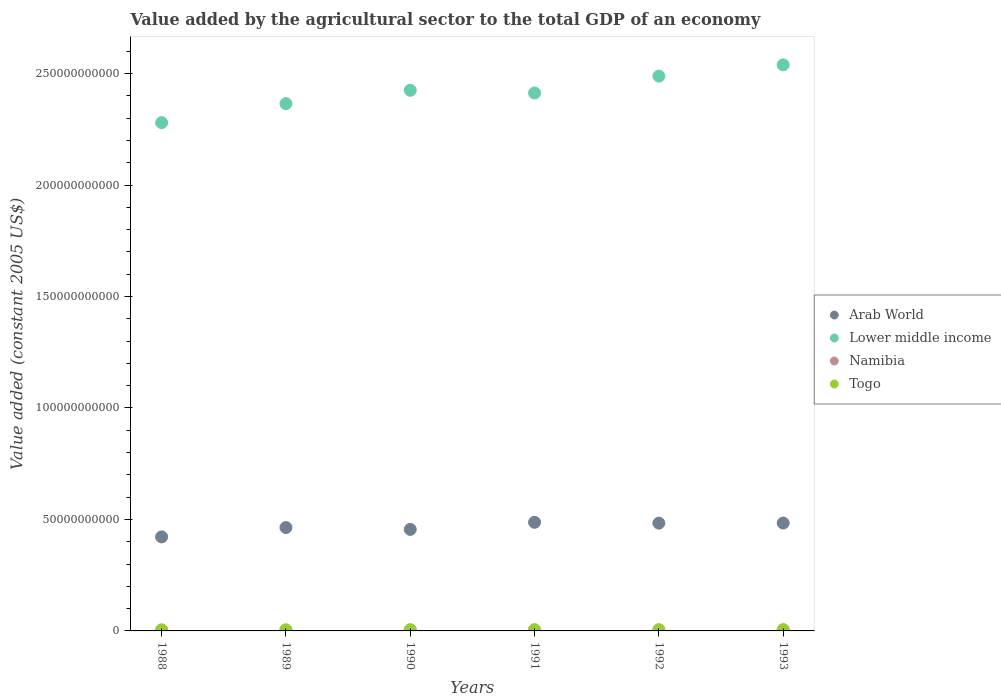How many different coloured dotlines are there?
Ensure brevity in your answer.  4. Is the number of dotlines equal to the number of legend labels?
Make the answer very short. Yes. What is the value added by the agricultural sector in Togo in 1992?
Offer a terse response. 5.30e+08. Across all years, what is the maximum value added by the agricultural sector in Lower middle income?
Provide a short and direct response. 2.54e+11. Across all years, what is the minimum value added by the agricultural sector in Togo?
Make the answer very short. 4.87e+08. In which year was the value added by the agricultural sector in Arab World minimum?
Your answer should be very brief. 1988. What is the total value added by the agricultural sector in Lower middle income in the graph?
Offer a very short reply. 1.45e+12. What is the difference between the value added by the agricultural sector in Togo in 1989 and that in 1991?
Ensure brevity in your answer.  -9.35e+06. What is the difference between the value added by the agricultural sector in Namibia in 1989 and the value added by the agricultural sector in Togo in 1990?
Give a very brief answer. -1.89e+08. What is the average value added by the agricultural sector in Arab World per year?
Provide a short and direct response. 4.66e+1. In the year 1990, what is the difference between the value added by the agricultural sector in Lower middle income and value added by the agricultural sector in Togo?
Provide a succinct answer. 2.42e+11. In how many years, is the value added by the agricultural sector in Namibia greater than 150000000000 US$?
Give a very brief answer. 0. What is the ratio of the value added by the agricultural sector in Arab World in 1988 to that in 1993?
Keep it short and to the point. 0.87. Is the value added by the agricultural sector in Lower middle income in 1989 less than that in 1990?
Provide a succinct answer. Yes. Is the difference between the value added by the agricultural sector in Lower middle income in 1990 and 1992 greater than the difference between the value added by the agricultural sector in Togo in 1990 and 1992?
Your answer should be compact. No. What is the difference between the highest and the second highest value added by the agricultural sector in Arab World?
Your response must be concise. 3.39e+08. What is the difference between the highest and the lowest value added by the agricultural sector in Togo?
Offer a terse response. 7.43e+07. Is the sum of the value added by the agricultural sector in Arab World in 1990 and 1993 greater than the maximum value added by the agricultural sector in Namibia across all years?
Give a very brief answer. Yes. Is it the case that in every year, the sum of the value added by the agricultural sector in Namibia and value added by the agricultural sector in Togo  is greater than the sum of value added by the agricultural sector in Arab World and value added by the agricultural sector in Lower middle income?
Provide a short and direct response. No. Is it the case that in every year, the sum of the value added by the agricultural sector in Arab World and value added by the agricultural sector in Namibia  is greater than the value added by the agricultural sector in Togo?
Provide a succinct answer. Yes. Does the value added by the agricultural sector in Namibia monotonically increase over the years?
Offer a terse response. No. How many dotlines are there?
Your response must be concise. 4. What is the difference between two consecutive major ticks on the Y-axis?
Your response must be concise. 5.00e+1. Are the values on the major ticks of Y-axis written in scientific E-notation?
Ensure brevity in your answer.  No. Does the graph contain grids?
Provide a succinct answer. No. Where does the legend appear in the graph?
Your response must be concise. Center right. What is the title of the graph?
Offer a terse response. Value added by the agricultural sector to the total GDP of an economy. Does "Sudan" appear as one of the legend labels in the graph?
Your response must be concise. No. What is the label or title of the Y-axis?
Offer a very short reply. Value added (constant 2005 US$). What is the Value added (constant 2005 US$) of Arab World in 1988?
Keep it short and to the point. 4.22e+1. What is the Value added (constant 2005 US$) in Lower middle income in 1988?
Your response must be concise. 2.28e+11. What is the Value added (constant 2005 US$) in Namibia in 1988?
Offer a very short reply. 3.42e+08. What is the Value added (constant 2005 US$) of Togo in 1988?
Give a very brief answer. 4.87e+08. What is the Value added (constant 2005 US$) in Arab World in 1989?
Make the answer very short. 4.64e+1. What is the Value added (constant 2005 US$) of Lower middle income in 1989?
Provide a short and direct response. 2.37e+11. What is the Value added (constant 2005 US$) in Namibia in 1989?
Give a very brief answer. 3.41e+08. What is the Value added (constant 2005 US$) of Togo in 1989?
Provide a short and direct response. 5.14e+08. What is the Value added (constant 2005 US$) in Arab World in 1990?
Your answer should be very brief. 4.55e+1. What is the Value added (constant 2005 US$) of Lower middle income in 1990?
Offer a terse response. 2.42e+11. What is the Value added (constant 2005 US$) of Namibia in 1990?
Provide a short and direct response. 4.04e+08. What is the Value added (constant 2005 US$) in Togo in 1990?
Offer a very short reply. 5.29e+08. What is the Value added (constant 2005 US$) in Arab World in 1991?
Give a very brief answer. 4.87e+1. What is the Value added (constant 2005 US$) of Lower middle income in 1991?
Give a very brief answer. 2.41e+11. What is the Value added (constant 2005 US$) of Namibia in 1991?
Keep it short and to the point. 4.61e+08. What is the Value added (constant 2005 US$) in Togo in 1991?
Your answer should be very brief. 5.23e+08. What is the Value added (constant 2005 US$) of Arab World in 1992?
Provide a succinct answer. 4.84e+1. What is the Value added (constant 2005 US$) in Lower middle income in 1992?
Provide a short and direct response. 2.49e+11. What is the Value added (constant 2005 US$) of Namibia in 1992?
Give a very brief answer. 4.40e+08. What is the Value added (constant 2005 US$) of Togo in 1992?
Ensure brevity in your answer.  5.30e+08. What is the Value added (constant 2005 US$) in Arab World in 1993?
Offer a terse response. 4.84e+1. What is the Value added (constant 2005 US$) in Lower middle income in 1993?
Your answer should be very brief. 2.54e+11. What is the Value added (constant 2005 US$) in Namibia in 1993?
Give a very brief answer. 4.82e+08. What is the Value added (constant 2005 US$) of Togo in 1993?
Provide a succinct answer. 5.61e+08. Across all years, what is the maximum Value added (constant 2005 US$) of Arab World?
Give a very brief answer. 4.87e+1. Across all years, what is the maximum Value added (constant 2005 US$) of Lower middle income?
Offer a terse response. 2.54e+11. Across all years, what is the maximum Value added (constant 2005 US$) of Namibia?
Keep it short and to the point. 4.82e+08. Across all years, what is the maximum Value added (constant 2005 US$) in Togo?
Your answer should be very brief. 5.61e+08. Across all years, what is the minimum Value added (constant 2005 US$) of Arab World?
Your answer should be very brief. 4.22e+1. Across all years, what is the minimum Value added (constant 2005 US$) in Lower middle income?
Provide a short and direct response. 2.28e+11. Across all years, what is the minimum Value added (constant 2005 US$) in Namibia?
Your answer should be compact. 3.41e+08. Across all years, what is the minimum Value added (constant 2005 US$) of Togo?
Ensure brevity in your answer.  4.87e+08. What is the total Value added (constant 2005 US$) of Arab World in the graph?
Provide a short and direct response. 2.80e+11. What is the total Value added (constant 2005 US$) in Lower middle income in the graph?
Provide a succinct answer. 1.45e+12. What is the total Value added (constant 2005 US$) of Namibia in the graph?
Offer a very short reply. 2.47e+09. What is the total Value added (constant 2005 US$) in Togo in the graph?
Ensure brevity in your answer.  3.14e+09. What is the difference between the Value added (constant 2005 US$) of Arab World in 1988 and that in 1989?
Ensure brevity in your answer.  -4.19e+09. What is the difference between the Value added (constant 2005 US$) in Lower middle income in 1988 and that in 1989?
Your response must be concise. -8.54e+09. What is the difference between the Value added (constant 2005 US$) in Namibia in 1988 and that in 1989?
Make the answer very short. 1.64e+06. What is the difference between the Value added (constant 2005 US$) in Togo in 1988 and that in 1989?
Make the answer very short. -2.68e+07. What is the difference between the Value added (constant 2005 US$) of Arab World in 1988 and that in 1990?
Offer a very short reply. -3.36e+09. What is the difference between the Value added (constant 2005 US$) in Lower middle income in 1988 and that in 1990?
Provide a short and direct response. -1.45e+1. What is the difference between the Value added (constant 2005 US$) in Namibia in 1988 and that in 1990?
Offer a terse response. -6.18e+07. What is the difference between the Value added (constant 2005 US$) of Togo in 1988 and that in 1990?
Give a very brief answer. -4.22e+07. What is the difference between the Value added (constant 2005 US$) in Arab World in 1988 and that in 1991?
Your answer should be compact. -6.56e+09. What is the difference between the Value added (constant 2005 US$) of Lower middle income in 1988 and that in 1991?
Ensure brevity in your answer.  -1.33e+1. What is the difference between the Value added (constant 2005 US$) in Namibia in 1988 and that in 1991?
Offer a very short reply. -1.18e+08. What is the difference between the Value added (constant 2005 US$) in Togo in 1988 and that in 1991?
Your answer should be compact. -3.61e+07. What is the difference between the Value added (constant 2005 US$) in Arab World in 1988 and that in 1992?
Provide a short and direct response. -6.18e+09. What is the difference between the Value added (constant 2005 US$) in Lower middle income in 1988 and that in 1992?
Your answer should be compact. -2.09e+1. What is the difference between the Value added (constant 2005 US$) of Namibia in 1988 and that in 1992?
Offer a very short reply. -9.81e+07. What is the difference between the Value added (constant 2005 US$) in Togo in 1988 and that in 1992?
Your answer should be very brief. -4.25e+07. What is the difference between the Value added (constant 2005 US$) in Arab World in 1988 and that in 1993?
Offer a very short reply. -6.22e+09. What is the difference between the Value added (constant 2005 US$) of Lower middle income in 1988 and that in 1993?
Keep it short and to the point. -2.59e+1. What is the difference between the Value added (constant 2005 US$) in Namibia in 1988 and that in 1993?
Provide a succinct answer. -1.39e+08. What is the difference between the Value added (constant 2005 US$) of Togo in 1988 and that in 1993?
Provide a short and direct response. -7.43e+07. What is the difference between the Value added (constant 2005 US$) of Arab World in 1989 and that in 1990?
Offer a very short reply. 8.31e+08. What is the difference between the Value added (constant 2005 US$) of Lower middle income in 1989 and that in 1990?
Your response must be concise. -5.97e+09. What is the difference between the Value added (constant 2005 US$) in Namibia in 1989 and that in 1990?
Provide a succinct answer. -6.34e+07. What is the difference between the Value added (constant 2005 US$) in Togo in 1989 and that in 1990?
Keep it short and to the point. -1.54e+07. What is the difference between the Value added (constant 2005 US$) in Arab World in 1989 and that in 1991?
Offer a terse response. -2.36e+09. What is the difference between the Value added (constant 2005 US$) of Lower middle income in 1989 and that in 1991?
Your response must be concise. -4.78e+09. What is the difference between the Value added (constant 2005 US$) in Namibia in 1989 and that in 1991?
Your answer should be compact. -1.20e+08. What is the difference between the Value added (constant 2005 US$) of Togo in 1989 and that in 1991?
Keep it short and to the point. -9.35e+06. What is the difference between the Value added (constant 2005 US$) in Arab World in 1989 and that in 1992?
Offer a very short reply. -1.98e+09. What is the difference between the Value added (constant 2005 US$) of Lower middle income in 1989 and that in 1992?
Keep it short and to the point. -1.23e+1. What is the difference between the Value added (constant 2005 US$) of Namibia in 1989 and that in 1992?
Provide a short and direct response. -9.97e+07. What is the difference between the Value added (constant 2005 US$) in Togo in 1989 and that in 1992?
Provide a short and direct response. -1.57e+07. What is the difference between the Value added (constant 2005 US$) in Arab World in 1989 and that in 1993?
Your response must be concise. -2.02e+09. What is the difference between the Value added (constant 2005 US$) of Lower middle income in 1989 and that in 1993?
Make the answer very short. -1.74e+1. What is the difference between the Value added (constant 2005 US$) of Namibia in 1989 and that in 1993?
Your answer should be compact. -1.41e+08. What is the difference between the Value added (constant 2005 US$) of Togo in 1989 and that in 1993?
Your answer should be very brief. -4.75e+07. What is the difference between the Value added (constant 2005 US$) in Arab World in 1990 and that in 1991?
Your answer should be compact. -3.19e+09. What is the difference between the Value added (constant 2005 US$) in Lower middle income in 1990 and that in 1991?
Provide a short and direct response. 1.19e+09. What is the difference between the Value added (constant 2005 US$) in Namibia in 1990 and that in 1991?
Your answer should be compact. -5.66e+07. What is the difference between the Value added (constant 2005 US$) in Togo in 1990 and that in 1991?
Your answer should be compact. 6.03e+06. What is the difference between the Value added (constant 2005 US$) of Arab World in 1990 and that in 1992?
Give a very brief answer. -2.81e+09. What is the difference between the Value added (constant 2005 US$) in Lower middle income in 1990 and that in 1992?
Offer a very short reply. -6.36e+09. What is the difference between the Value added (constant 2005 US$) in Namibia in 1990 and that in 1992?
Provide a short and direct response. -3.63e+07. What is the difference between the Value added (constant 2005 US$) in Togo in 1990 and that in 1992?
Give a very brief answer. -3.74e+05. What is the difference between the Value added (constant 2005 US$) of Arab World in 1990 and that in 1993?
Make the answer very short. -2.86e+09. What is the difference between the Value added (constant 2005 US$) of Lower middle income in 1990 and that in 1993?
Make the answer very short. -1.14e+1. What is the difference between the Value added (constant 2005 US$) of Namibia in 1990 and that in 1993?
Your answer should be very brief. -7.75e+07. What is the difference between the Value added (constant 2005 US$) in Togo in 1990 and that in 1993?
Give a very brief answer. -3.21e+07. What is the difference between the Value added (constant 2005 US$) of Arab World in 1991 and that in 1992?
Offer a terse response. 3.80e+08. What is the difference between the Value added (constant 2005 US$) in Lower middle income in 1991 and that in 1992?
Keep it short and to the point. -7.55e+09. What is the difference between the Value added (constant 2005 US$) in Namibia in 1991 and that in 1992?
Provide a short and direct response. 2.03e+07. What is the difference between the Value added (constant 2005 US$) in Togo in 1991 and that in 1992?
Make the answer very short. -6.40e+06. What is the difference between the Value added (constant 2005 US$) in Arab World in 1991 and that in 1993?
Provide a short and direct response. 3.39e+08. What is the difference between the Value added (constant 2005 US$) in Lower middle income in 1991 and that in 1993?
Keep it short and to the point. -1.26e+1. What is the difference between the Value added (constant 2005 US$) in Namibia in 1991 and that in 1993?
Ensure brevity in your answer.  -2.09e+07. What is the difference between the Value added (constant 2005 US$) in Togo in 1991 and that in 1993?
Give a very brief answer. -3.81e+07. What is the difference between the Value added (constant 2005 US$) of Arab World in 1992 and that in 1993?
Provide a succinct answer. -4.10e+07. What is the difference between the Value added (constant 2005 US$) of Lower middle income in 1992 and that in 1993?
Ensure brevity in your answer.  -5.06e+09. What is the difference between the Value added (constant 2005 US$) in Namibia in 1992 and that in 1993?
Keep it short and to the point. -4.11e+07. What is the difference between the Value added (constant 2005 US$) in Togo in 1992 and that in 1993?
Your answer should be very brief. -3.17e+07. What is the difference between the Value added (constant 2005 US$) of Arab World in 1988 and the Value added (constant 2005 US$) of Lower middle income in 1989?
Ensure brevity in your answer.  -1.94e+11. What is the difference between the Value added (constant 2005 US$) of Arab World in 1988 and the Value added (constant 2005 US$) of Namibia in 1989?
Your answer should be compact. 4.18e+1. What is the difference between the Value added (constant 2005 US$) of Arab World in 1988 and the Value added (constant 2005 US$) of Togo in 1989?
Your answer should be compact. 4.17e+1. What is the difference between the Value added (constant 2005 US$) of Lower middle income in 1988 and the Value added (constant 2005 US$) of Namibia in 1989?
Make the answer very short. 2.28e+11. What is the difference between the Value added (constant 2005 US$) of Lower middle income in 1988 and the Value added (constant 2005 US$) of Togo in 1989?
Keep it short and to the point. 2.27e+11. What is the difference between the Value added (constant 2005 US$) in Namibia in 1988 and the Value added (constant 2005 US$) in Togo in 1989?
Your answer should be very brief. -1.72e+08. What is the difference between the Value added (constant 2005 US$) of Arab World in 1988 and the Value added (constant 2005 US$) of Lower middle income in 1990?
Your response must be concise. -2.00e+11. What is the difference between the Value added (constant 2005 US$) in Arab World in 1988 and the Value added (constant 2005 US$) in Namibia in 1990?
Provide a succinct answer. 4.18e+1. What is the difference between the Value added (constant 2005 US$) in Arab World in 1988 and the Value added (constant 2005 US$) in Togo in 1990?
Provide a short and direct response. 4.16e+1. What is the difference between the Value added (constant 2005 US$) of Lower middle income in 1988 and the Value added (constant 2005 US$) of Namibia in 1990?
Give a very brief answer. 2.28e+11. What is the difference between the Value added (constant 2005 US$) in Lower middle income in 1988 and the Value added (constant 2005 US$) in Togo in 1990?
Provide a succinct answer. 2.27e+11. What is the difference between the Value added (constant 2005 US$) of Namibia in 1988 and the Value added (constant 2005 US$) of Togo in 1990?
Give a very brief answer. -1.87e+08. What is the difference between the Value added (constant 2005 US$) of Arab World in 1988 and the Value added (constant 2005 US$) of Lower middle income in 1991?
Provide a short and direct response. -1.99e+11. What is the difference between the Value added (constant 2005 US$) of Arab World in 1988 and the Value added (constant 2005 US$) of Namibia in 1991?
Offer a terse response. 4.17e+1. What is the difference between the Value added (constant 2005 US$) in Arab World in 1988 and the Value added (constant 2005 US$) in Togo in 1991?
Give a very brief answer. 4.16e+1. What is the difference between the Value added (constant 2005 US$) of Lower middle income in 1988 and the Value added (constant 2005 US$) of Namibia in 1991?
Keep it short and to the point. 2.28e+11. What is the difference between the Value added (constant 2005 US$) of Lower middle income in 1988 and the Value added (constant 2005 US$) of Togo in 1991?
Offer a very short reply. 2.27e+11. What is the difference between the Value added (constant 2005 US$) of Namibia in 1988 and the Value added (constant 2005 US$) of Togo in 1991?
Your response must be concise. -1.81e+08. What is the difference between the Value added (constant 2005 US$) in Arab World in 1988 and the Value added (constant 2005 US$) in Lower middle income in 1992?
Your response must be concise. -2.07e+11. What is the difference between the Value added (constant 2005 US$) of Arab World in 1988 and the Value added (constant 2005 US$) of Namibia in 1992?
Provide a succinct answer. 4.17e+1. What is the difference between the Value added (constant 2005 US$) in Arab World in 1988 and the Value added (constant 2005 US$) in Togo in 1992?
Offer a very short reply. 4.16e+1. What is the difference between the Value added (constant 2005 US$) in Lower middle income in 1988 and the Value added (constant 2005 US$) in Namibia in 1992?
Give a very brief answer. 2.28e+11. What is the difference between the Value added (constant 2005 US$) in Lower middle income in 1988 and the Value added (constant 2005 US$) in Togo in 1992?
Keep it short and to the point. 2.27e+11. What is the difference between the Value added (constant 2005 US$) in Namibia in 1988 and the Value added (constant 2005 US$) in Togo in 1992?
Ensure brevity in your answer.  -1.87e+08. What is the difference between the Value added (constant 2005 US$) of Arab World in 1988 and the Value added (constant 2005 US$) of Lower middle income in 1993?
Make the answer very short. -2.12e+11. What is the difference between the Value added (constant 2005 US$) in Arab World in 1988 and the Value added (constant 2005 US$) in Namibia in 1993?
Offer a terse response. 4.17e+1. What is the difference between the Value added (constant 2005 US$) in Arab World in 1988 and the Value added (constant 2005 US$) in Togo in 1993?
Your answer should be compact. 4.16e+1. What is the difference between the Value added (constant 2005 US$) of Lower middle income in 1988 and the Value added (constant 2005 US$) of Namibia in 1993?
Keep it short and to the point. 2.27e+11. What is the difference between the Value added (constant 2005 US$) in Lower middle income in 1988 and the Value added (constant 2005 US$) in Togo in 1993?
Ensure brevity in your answer.  2.27e+11. What is the difference between the Value added (constant 2005 US$) in Namibia in 1988 and the Value added (constant 2005 US$) in Togo in 1993?
Offer a terse response. -2.19e+08. What is the difference between the Value added (constant 2005 US$) of Arab World in 1989 and the Value added (constant 2005 US$) of Lower middle income in 1990?
Your answer should be compact. -1.96e+11. What is the difference between the Value added (constant 2005 US$) of Arab World in 1989 and the Value added (constant 2005 US$) of Namibia in 1990?
Provide a succinct answer. 4.60e+1. What is the difference between the Value added (constant 2005 US$) in Arab World in 1989 and the Value added (constant 2005 US$) in Togo in 1990?
Offer a very short reply. 4.58e+1. What is the difference between the Value added (constant 2005 US$) in Lower middle income in 1989 and the Value added (constant 2005 US$) in Namibia in 1990?
Ensure brevity in your answer.  2.36e+11. What is the difference between the Value added (constant 2005 US$) in Lower middle income in 1989 and the Value added (constant 2005 US$) in Togo in 1990?
Ensure brevity in your answer.  2.36e+11. What is the difference between the Value added (constant 2005 US$) in Namibia in 1989 and the Value added (constant 2005 US$) in Togo in 1990?
Your response must be concise. -1.89e+08. What is the difference between the Value added (constant 2005 US$) in Arab World in 1989 and the Value added (constant 2005 US$) in Lower middle income in 1991?
Offer a very short reply. -1.95e+11. What is the difference between the Value added (constant 2005 US$) in Arab World in 1989 and the Value added (constant 2005 US$) in Namibia in 1991?
Your answer should be very brief. 4.59e+1. What is the difference between the Value added (constant 2005 US$) of Arab World in 1989 and the Value added (constant 2005 US$) of Togo in 1991?
Offer a terse response. 4.58e+1. What is the difference between the Value added (constant 2005 US$) of Lower middle income in 1989 and the Value added (constant 2005 US$) of Namibia in 1991?
Provide a succinct answer. 2.36e+11. What is the difference between the Value added (constant 2005 US$) of Lower middle income in 1989 and the Value added (constant 2005 US$) of Togo in 1991?
Provide a short and direct response. 2.36e+11. What is the difference between the Value added (constant 2005 US$) in Namibia in 1989 and the Value added (constant 2005 US$) in Togo in 1991?
Your response must be concise. -1.82e+08. What is the difference between the Value added (constant 2005 US$) of Arab World in 1989 and the Value added (constant 2005 US$) of Lower middle income in 1992?
Give a very brief answer. -2.02e+11. What is the difference between the Value added (constant 2005 US$) of Arab World in 1989 and the Value added (constant 2005 US$) of Namibia in 1992?
Offer a terse response. 4.59e+1. What is the difference between the Value added (constant 2005 US$) of Arab World in 1989 and the Value added (constant 2005 US$) of Togo in 1992?
Make the answer very short. 4.58e+1. What is the difference between the Value added (constant 2005 US$) of Lower middle income in 1989 and the Value added (constant 2005 US$) of Namibia in 1992?
Your answer should be compact. 2.36e+11. What is the difference between the Value added (constant 2005 US$) of Lower middle income in 1989 and the Value added (constant 2005 US$) of Togo in 1992?
Your response must be concise. 2.36e+11. What is the difference between the Value added (constant 2005 US$) of Namibia in 1989 and the Value added (constant 2005 US$) of Togo in 1992?
Make the answer very short. -1.89e+08. What is the difference between the Value added (constant 2005 US$) of Arab World in 1989 and the Value added (constant 2005 US$) of Lower middle income in 1993?
Give a very brief answer. -2.08e+11. What is the difference between the Value added (constant 2005 US$) of Arab World in 1989 and the Value added (constant 2005 US$) of Namibia in 1993?
Offer a terse response. 4.59e+1. What is the difference between the Value added (constant 2005 US$) in Arab World in 1989 and the Value added (constant 2005 US$) in Togo in 1993?
Keep it short and to the point. 4.58e+1. What is the difference between the Value added (constant 2005 US$) of Lower middle income in 1989 and the Value added (constant 2005 US$) of Namibia in 1993?
Give a very brief answer. 2.36e+11. What is the difference between the Value added (constant 2005 US$) in Lower middle income in 1989 and the Value added (constant 2005 US$) in Togo in 1993?
Provide a succinct answer. 2.36e+11. What is the difference between the Value added (constant 2005 US$) of Namibia in 1989 and the Value added (constant 2005 US$) of Togo in 1993?
Ensure brevity in your answer.  -2.21e+08. What is the difference between the Value added (constant 2005 US$) in Arab World in 1990 and the Value added (constant 2005 US$) in Lower middle income in 1991?
Your answer should be very brief. -1.96e+11. What is the difference between the Value added (constant 2005 US$) of Arab World in 1990 and the Value added (constant 2005 US$) of Namibia in 1991?
Give a very brief answer. 4.51e+1. What is the difference between the Value added (constant 2005 US$) in Arab World in 1990 and the Value added (constant 2005 US$) in Togo in 1991?
Make the answer very short. 4.50e+1. What is the difference between the Value added (constant 2005 US$) in Lower middle income in 1990 and the Value added (constant 2005 US$) in Namibia in 1991?
Offer a terse response. 2.42e+11. What is the difference between the Value added (constant 2005 US$) of Lower middle income in 1990 and the Value added (constant 2005 US$) of Togo in 1991?
Offer a very short reply. 2.42e+11. What is the difference between the Value added (constant 2005 US$) of Namibia in 1990 and the Value added (constant 2005 US$) of Togo in 1991?
Make the answer very short. -1.19e+08. What is the difference between the Value added (constant 2005 US$) in Arab World in 1990 and the Value added (constant 2005 US$) in Lower middle income in 1992?
Make the answer very short. -2.03e+11. What is the difference between the Value added (constant 2005 US$) of Arab World in 1990 and the Value added (constant 2005 US$) of Namibia in 1992?
Keep it short and to the point. 4.51e+1. What is the difference between the Value added (constant 2005 US$) in Arab World in 1990 and the Value added (constant 2005 US$) in Togo in 1992?
Make the answer very short. 4.50e+1. What is the difference between the Value added (constant 2005 US$) of Lower middle income in 1990 and the Value added (constant 2005 US$) of Namibia in 1992?
Provide a succinct answer. 2.42e+11. What is the difference between the Value added (constant 2005 US$) of Lower middle income in 1990 and the Value added (constant 2005 US$) of Togo in 1992?
Ensure brevity in your answer.  2.42e+11. What is the difference between the Value added (constant 2005 US$) in Namibia in 1990 and the Value added (constant 2005 US$) in Togo in 1992?
Offer a very short reply. -1.25e+08. What is the difference between the Value added (constant 2005 US$) of Arab World in 1990 and the Value added (constant 2005 US$) of Lower middle income in 1993?
Give a very brief answer. -2.08e+11. What is the difference between the Value added (constant 2005 US$) of Arab World in 1990 and the Value added (constant 2005 US$) of Namibia in 1993?
Provide a succinct answer. 4.51e+1. What is the difference between the Value added (constant 2005 US$) of Arab World in 1990 and the Value added (constant 2005 US$) of Togo in 1993?
Ensure brevity in your answer.  4.50e+1. What is the difference between the Value added (constant 2005 US$) of Lower middle income in 1990 and the Value added (constant 2005 US$) of Namibia in 1993?
Your response must be concise. 2.42e+11. What is the difference between the Value added (constant 2005 US$) of Lower middle income in 1990 and the Value added (constant 2005 US$) of Togo in 1993?
Make the answer very short. 2.42e+11. What is the difference between the Value added (constant 2005 US$) in Namibia in 1990 and the Value added (constant 2005 US$) in Togo in 1993?
Offer a terse response. -1.57e+08. What is the difference between the Value added (constant 2005 US$) in Arab World in 1991 and the Value added (constant 2005 US$) in Lower middle income in 1992?
Provide a succinct answer. -2.00e+11. What is the difference between the Value added (constant 2005 US$) in Arab World in 1991 and the Value added (constant 2005 US$) in Namibia in 1992?
Give a very brief answer. 4.83e+1. What is the difference between the Value added (constant 2005 US$) in Arab World in 1991 and the Value added (constant 2005 US$) in Togo in 1992?
Make the answer very short. 4.82e+1. What is the difference between the Value added (constant 2005 US$) in Lower middle income in 1991 and the Value added (constant 2005 US$) in Namibia in 1992?
Offer a very short reply. 2.41e+11. What is the difference between the Value added (constant 2005 US$) of Lower middle income in 1991 and the Value added (constant 2005 US$) of Togo in 1992?
Provide a short and direct response. 2.41e+11. What is the difference between the Value added (constant 2005 US$) of Namibia in 1991 and the Value added (constant 2005 US$) of Togo in 1992?
Ensure brevity in your answer.  -6.89e+07. What is the difference between the Value added (constant 2005 US$) of Arab World in 1991 and the Value added (constant 2005 US$) of Lower middle income in 1993?
Your response must be concise. -2.05e+11. What is the difference between the Value added (constant 2005 US$) of Arab World in 1991 and the Value added (constant 2005 US$) of Namibia in 1993?
Keep it short and to the point. 4.82e+1. What is the difference between the Value added (constant 2005 US$) of Arab World in 1991 and the Value added (constant 2005 US$) of Togo in 1993?
Offer a terse response. 4.82e+1. What is the difference between the Value added (constant 2005 US$) of Lower middle income in 1991 and the Value added (constant 2005 US$) of Namibia in 1993?
Offer a very short reply. 2.41e+11. What is the difference between the Value added (constant 2005 US$) in Lower middle income in 1991 and the Value added (constant 2005 US$) in Togo in 1993?
Your answer should be compact. 2.41e+11. What is the difference between the Value added (constant 2005 US$) in Namibia in 1991 and the Value added (constant 2005 US$) in Togo in 1993?
Offer a very short reply. -1.01e+08. What is the difference between the Value added (constant 2005 US$) in Arab World in 1992 and the Value added (constant 2005 US$) in Lower middle income in 1993?
Ensure brevity in your answer.  -2.06e+11. What is the difference between the Value added (constant 2005 US$) in Arab World in 1992 and the Value added (constant 2005 US$) in Namibia in 1993?
Ensure brevity in your answer.  4.79e+1. What is the difference between the Value added (constant 2005 US$) of Arab World in 1992 and the Value added (constant 2005 US$) of Togo in 1993?
Make the answer very short. 4.78e+1. What is the difference between the Value added (constant 2005 US$) of Lower middle income in 1992 and the Value added (constant 2005 US$) of Namibia in 1993?
Ensure brevity in your answer.  2.48e+11. What is the difference between the Value added (constant 2005 US$) in Lower middle income in 1992 and the Value added (constant 2005 US$) in Togo in 1993?
Keep it short and to the point. 2.48e+11. What is the difference between the Value added (constant 2005 US$) of Namibia in 1992 and the Value added (constant 2005 US$) of Togo in 1993?
Your answer should be very brief. -1.21e+08. What is the average Value added (constant 2005 US$) in Arab World per year?
Provide a succinct answer. 4.66e+1. What is the average Value added (constant 2005 US$) in Lower middle income per year?
Ensure brevity in your answer.  2.42e+11. What is the average Value added (constant 2005 US$) of Namibia per year?
Offer a terse response. 4.12e+08. What is the average Value added (constant 2005 US$) in Togo per year?
Keep it short and to the point. 5.24e+08. In the year 1988, what is the difference between the Value added (constant 2005 US$) of Arab World and Value added (constant 2005 US$) of Lower middle income?
Keep it short and to the point. -1.86e+11. In the year 1988, what is the difference between the Value added (constant 2005 US$) in Arab World and Value added (constant 2005 US$) in Namibia?
Offer a very short reply. 4.18e+1. In the year 1988, what is the difference between the Value added (constant 2005 US$) of Arab World and Value added (constant 2005 US$) of Togo?
Offer a very short reply. 4.17e+1. In the year 1988, what is the difference between the Value added (constant 2005 US$) of Lower middle income and Value added (constant 2005 US$) of Namibia?
Keep it short and to the point. 2.28e+11. In the year 1988, what is the difference between the Value added (constant 2005 US$) of Lower middle income and Value added (constant 2005 US$) of Togo?
Offer a very short reply. 2.27e+11. In the year 1988, what is the difference between the Value added (constant 2005 US$) of Namibia and Value added (constant 2005 US$) of Togo?
Offer a very short reply. -1.45e+08. In the year 1989, what is the difference between the Value added (constant 2005 US$) of Arab World and Value added (constant 2005 US$) of Lower middle income?
Your answer should be compact. -1.90e+11. In the year 1989, what is the difference between the Value added (constant 2005 US$) in Arab World and Value added (constant 2005 US$) in Namibia?
Give a very brief answer. 4.60e+1. In the year 1989, what is the difference between the Value added (constant 2005 US$) in Arab World and Value added (constant 2005 US$) in Togo?
Give a very brief answer. 4.59e+1. In the year 1989, what is the difference between the Value added (constant 2005 US$) in Lower middle income and Value added (constant 2005 US$) in Namibia?
Keep it short and to the point. 2.36e+11. In the year 1989, what is the difference between the Value added (constant 2005 US$) in Lower middle income and Value added (constant 2005 US$) in Togo?
Provide a succinct answer. 2.36e+11. In the year 1989, what is the difference between the Value added (constant 2005 US$) of Namibia and Value added (constant 2005 US$) of Togo?
Ensure brevity in your answer.  -1.73e+08. In the year 1990, what is the difference between the Value added (constant 2005 US$) of Arab World and Value added (constant 2005 US$) of Lower middle income?
Provide a short and direct response. -1.97e+11. In the year 1990, what is the difference between the Value added (constant 2005 US$) in Arab World and Value added (constant 2005 US$) in Namibia?
Offer a very short reply. 4.51e+1. In the year 1990, what is the difference between the Value added (constant 2005 US$) of Arab World and Value added (constant 2005 US$) of Togo?
Provide a succinct answer. 4.50e+1. In the year 1990, what is the difference between the Value added (constant 2005 US$) of Lower middle income and Value added (constant 2005 US$) of Namibia?
Your answer should be compact. 2.42e+11. In the year 1990, what is the difference between the Value added (constant 2005 US$) in Lower middle income and Value added (constant 2005 US$) in Togo?
Provide a short and direct response. 2.42e+11. In the year 1990, what is the difference between the Value added (constant 2005 US$) in Namibia and Value added (constant 2005 US$) in Togo?
Provide a short and direct response. -1.25e+08. In the year 1991, what is the difference between the Value added (constant 2005 US$) of Arab World and Value added (constant 2005 US$) of Lower middle income?
Your answer should be compact. -1.93e+11. In the year 1991, what is the difference between the Value added (constant 2005 US$) in Arab World and Value added (constant 2005 US$) in Namibia?
Keep it short and to the point. 4.83e+1. In the year 1991, what is the difference between the Value added (constant 2005 US$) in Arab World and Value added (constant 2005 US$) in Togo?
Give a very brief answer. 4.82e+1. In the year 1991, what is the difference between the Value added (constant 2005 US$) in Lower middle income and Value added (constant 2005 US$) in Namibia?
Offer a terse response. 2.41e+11. In the year 1991, what is the difference between the Value added (constant 2005 US$) in Lower middle income and Value added (constant 2005 US$) in Togo?
Provide a succinct answer. 2.41e+11. In the year 1991, what is the difference between the Value added (constant 2005 US$) of Namibia and Value added (constant 2005 US$) of Togo?
Ensure brevity in your answer.  -6.25e+07. In the year 1992, what is the difference between the Value added (constant 2005 US$) of Arab World and Value added (constant 2005 US$) of Lower middle income?
Give a very brief answer. -2.00e+11. In the year 1992, what is the difference between the Value added (constant 2005 US$) of Arab World and Value added (constant 2005 US$) of Namibia?
Offer a terse response. 4.79e+1. In the year 1992, what is the difference between the Value added (constant 2005 US$) in Arab World and Value added (constant 2005 US$) in Togo?
Ensure brevity in your answer.  4.78e+1. In the year 1992, what is the difference between the Value added (constant 2005 US$) of Lower middle income and Value added (constant 2005 US$) of Namibia?
Your answer should be compact. 2.48e+11. In the year 1992, what is the difference between the Value added (constant 2005 US$) of Lower middle income and Value added (constant 2005 US$) of Togo?
Keep it short and to the point. 2.48e+11. In the year 1992, what is the difference between the Value added (constant 2005 US$) in Namibia and Value added (constant 2005 US$) in Togo?
Provide a succinct answer. -8.92e+07. In the year 1993, what is the difference between the Value added (constant 2005 US$) of Arab World and Value added (constant 2005 US$) of Lower middle income?
Offer a terse response. -2.06e+11. In the year 1993, what is the difference between the Value added (constant 2005 US$) of Arab World and Value added (constant 2005 US$) of Namibia?
Provide a succinct answer. 4.79e+1. In the year 1993, what is the difference between the Value added (constant 2005 US$) in Arab World and Value added (constant 2005 US$) in Togo?
Offer a terse response. 4.78e+1. In the year 1993, what is the difference between the Value added (constant 2005 US$) in Lower middle income and Value added (constant 2005 US$) in Namibia?
Provide a succinct answer. 2.53e+11. In the year 1993, what is the difference between the Value added (constant 2005 US$) of Lower middle income and Value added (constant 2005 US$) of Togo?
Offer a terse response. 2.53e+11. In the year 1993, what is the difference between the Value added (constant 2005 US$) of Namibia and Value added (constant 2005 US$) of Togo?
Ensure brevity in your answer.  -7.98e+07. What is the ratio of the Value added (constant 2005 US$) in Arab World in 1988 to that in 1989?
Keep it short and to the point. 0.91. What is the ratio of the Value added (constant 2005 US$) of Lower middle income in 1988 to that in 1989?
Provide a short and direct response. 0.96. What is the ratio of the Value added (constant 2005 US$) in Namibia in 1988 to that in 1989?
Keep it short and to the point. 1. What is the ratio of the Value added (constant 2005 US$) of Togo in 1988 to that in 1989?
Your response must be concise. 0.95. What is the ratio of the Value added (constant 2005 US$) of Arab World in 1988 to that in 1990?
Keep it short and to the point. 0.93. What is the ratio of the Value added (constant 2005 US$) of Lower middle income in 1988 to that in 1990?
Offer a very short reply. 0.94. What is the ratio of the Value added (constant 2005 US$) in Namibia in 1988 to that in 1990?
Your response must be concise. 0.85. What is the ratio of the Value added (constant 2005 US$) of Togo in 1988 to that in 1990?
Your response must be concise. 0.92. What is the ratio of the Value added (constant 2005 US$) of Arab World in 1988 to that in 1991?
Keep it short and to the point. 0.87. What is the ratio of the Value added (constant 2005 US$) of Lower middle income in 1988 to that in 1991?
Ensure brevity in your answer.  0.94. What is the ratio of the Value added (constant 2005 US$) of Namibia in 1988 to that in 1991?
Offer a very short reply. 0.74. What is the ratio of the Value added (constant 2005 US$) in Togo in 1988 to that in 1991?
Your answer should be very brief. 0.93. What is the ratio of the Value added (constant 2005 US$) of Arab World in 1988 to that in 1992?
Keep it short and to the point. 0.87. What is the ratio of the Value added (constant 2005 US$) of Lower middle income in 1988 to that in 1992?
Ensure brevity in your answer.  0.92. What is the ratio of the Value added (constant 2005 US$) of Namibia in 1988 to that in 1992?
Offer a very short reply. 0.78. What is the ratio of the Value added (constant 2005 US$) of Togo in 1988 to that in 1992?
Keep it short and to the point. 0.92. What is the ratio of the Value added (constant 2005 US$) of Arab World in 1988 to that in 1993?
Your response must be concise. 0.87. What is the ratio of the Value added (constant 2005 US$) of Lower middle income in 1988 to that in 1993?
Give a very brief answer. 0.9. What is the ratio of the Value added (constant 2005 US$) of Namibia in 1988 to that in 1993?
Offer a terse response. 0.71. What is the ratio of the Value added (constant 2005 US$) in Togo in 1988 to that in 1993?
Offer a terse response. 0.87. What is the ratio of the Value added (constant 2005 US$) of Arab World in 1989 to that in 1990?
Your answer should be very brief. 1.02. What is the ratio of the Value added (constant 2005 US$) in Lower middle income in 1989 to that in 1990?
Give a very brief answer. 0.98. What is the ratio of the Value added (constant 2005 US$) in Namibia in 1989 to that in 1990?
Keep it short and to the point. 0.84. What is the ratio of the Value added (constant 2005 US$) of Togo in 1989 to that in 1990?
Ensure brevity in your answer.  0.97. What is the ratio of the Value added (constant 2005 US$) in Arab World in 1989 to that in 1991?
Give a very brief answer. 0.95. What is the ratio of the Value added (constant 2005 US$) in Lower middle income in 1989 to that in 1991?
Your answer should be very brief. 0.98. What is the ratio of the Value added (constant 2005 US$) in Namibia in 1989 to that in 1991?
Your response must be concise. 0.74. What is the ratio of the Value added (constant 2005 US$) in Togo in 1989 to that in 1991?
Ensure brevity in your answer.  0.98. What is the ratio of the Value added (constant 2005 US$) of Lower middle income in 1989 to that in 1992?
Keep it short and to the point. 0.95. What is the ratio of the Value added (constant 2005 US$) in Namibia in 1989 to that in 1992?
Your response must be concise. 0.77. What is the ratio of the Value added (constant 2005 US$) in Togo in 1989 to that in 1992?
Make the answer very short. 0.97. What is the ratio of the Value added (constant 2005 US$) in Arab World in 1989 to that in 1993?
Provide a short and direct response. 0.96. What is the ratio of the Value added (constant 2005 US$) of Lower middle income in 1989 to that in 1993?
Make the answer very short. 0.93. What is the ratio of the Value added (constant 2005 US$) in Namibia in 1989 to that in 1993?
Your answer should be very brief. 0.71. What is the ratio of the Value added (constant 2005 US$) in Togo in 1989 to that in 1993?
Ensure brevity in your answer.  0.92. What is the ratio of the Value added (constant 2005 US$) of Arab World in 1990 to that in 1991?
Give a very brief answer. 0.93. What is the ratio of the Value added (constant 2005 US$) of Namibia in 1990 to that in 1991?
Your answer should be compact. 0.88. What is the ratio of the Value added (constant 2005 US$) in Togo in 1990 to that in 1991?
Your answer should be very brief. 1.01. What is the ratio of the Value added (constant 2005 US$) in Arab World in 1990 to that in 1992?
Keep it short and to the point. 0.94. What is the ratio of the Value added (constant 2005 US$) of Lower middle income in 1990 to that in 1992?
Provide a short and direct response. 0.97. What is the ratio of the Value added (constant 2005 US$) in Namibia in 1990 to that in 1992?
Your answer should be compact. 0.92. What is the ratio of the Value added (constant 2005 US$) of Arab World in 1990 to that in 1993?
Provide a short and direct response. 0.94. What is the ratio of the Value added (constant 2005 US$) of Lower middle income in 1990 to that in 1993?
Offer a very short reply. 0.95. What is the ratio of the Value added (constant 2005 US$) of Namibia in 1990 to that in 1993?
Make the answer very short. 0.84. What is the ratio of the Value added (constant 2005 US$) in Togo in 1990 to that in 1993?
Your response must be concise. 0.94. What is the ratio of the Value added (constant 2005 US$) of Lower middle income in 1991 to that in 1992?
Ensure brevity in your answer.  0.97. What is the ratio of the Value added (constant 2005 US$) of Namibia in 1991 to that in 1992?
Offer a terse response. 1.05. What is the ratio of the Value added (constant 2005 US$) of Togo in 1991 to that in 1992?
Provide a short and direct response. 0.99. What is the ratio of the Value added (constant 2005 US$) of Arab World in 1991 to that in 1993?
Offer a terse response. 1.01. What is the ratio of the Value added (constant 2005 US$) in Lower middle income in 1991 to that in 1993?
Your answer should be very brief. 0.95. What is the ratio of the Value added (constant 2005 US$) of Namibia in 1991 to that in 1993?
Your answer should be very brief. 0.96. What is the ratio of the Value added (constant 2005 US$) in Togo in 1991 to that in 1993?
Make the answer very short. 0.93. What is the ratio of the Value added (constant 2005 US$) in Arab World in 1992 to that in 1993?
Keep it short and to the point. 1. What is the ratio of the Value added (constant 2005 US$) of Lower middle income in 1992 to that in 1993?
Your response must be concise. 0.98. What is the ratio of the Value added (constant 2005 US$) of Namibia in 1992 to that in 1993?
Keep it short and to the point. 0.91. What is the ratio of the Value added (constant 2005 US$) in Togo in 1992 to that in 1993?
Your answer should be compact. 0.94. What is the difference between the highest and the second highest Value added (constant 2005 US$) in Arab World?
Provide a short and direct response. 3.39e+08. What is the difference between the highest and the second highest Value added (constant 2005 US$) in Lower middle income?
Offer a terse response. 5.06e+09. What is the difference between the highest and the second highest Value added (constant 2005 US$) of Namibia?
Give a very brief answer. 2.09e+07. What is the difference between the highest and the second highest Value added (constant 2005 US$) of Togo?
Keep it short and to the point. 3.17e+07. What is the difference between the highest and the lowest Value added (constant 2005 US$) of Arab World?
Make the answer very short. 6.56e+09. What is the difference between the highest and the lowest Value added (constant 2005 US$) of Lower middle income?
Your answer should be compact. 2.59e+1. What is the difference between the highest and the lowest Value added (constant 2005 US$) in Namibia?
Your answer should be compact. 1.41e+08. What is the difference between the highest and the lowest Value added (constant 2005 US$) of Togo?
Your response must be concise. 7.43e+07. 